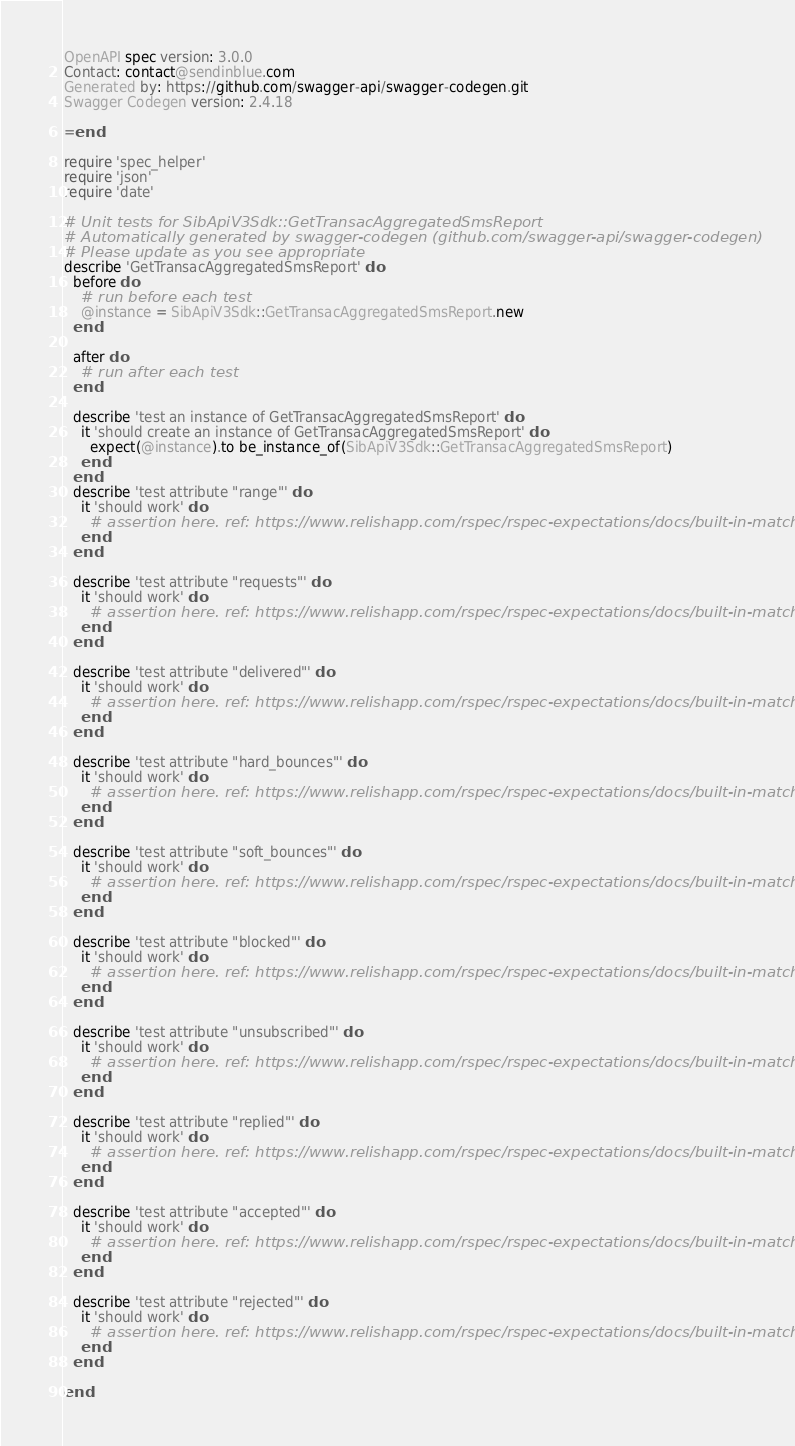Convert code to text. <code><loc_0><loc_0><loc_500><loc_500><_Ruby_>
OpenAPI spec version: 3.0.0
Contact: contact@sendinblue.com
Generated by: https://github.com/swagger-api/swagger-codegen.git
Swagger Codegen version: 2.4.18

=end

require 'spec_helper'
require 'json'
require 'date'

# Unit tests for SibApiV3Sdk::GetTransacAggregatedSmsReport
# Automatically generated by swagger-codegen (github.com/swagger-api/swagger-codegen)
# Please update as you see appropriate
describe 'GetTransacAggregatedSmsReport' do
  before do
    # run before each test
    @instance = SibApiV3Sdk::GetTransacAggregatedSmsReport.new
  end

  after do
    # run after each test
  end

  describe 'test an instance of GetTransacAggregatedSmsReport' do
    it 'should create an instance of GetTransacAggregatedSmsReport' do
      expect(@instance).to be_instance_of(SibApiV3Sdk::GetTransacAggregatedSmsReport)
    end
  end
  describe 'test attribute "range"' do
    it 'should work' do
      # assertion here. ref: https://www.relishapp.com/rspec/rspec-expectations/docs/built-in-matchers
    end
  end

  describe 'test attribute "requests"' do
    it 'should work' do
      # assertion here. ref: https://www.relishapp.com/rspec/rspec-expectations/docs/built-in-matchers
    end
  end

  describe 'test attribute "delivered"' do
    it 'should work' do
      # assertion here. ref: https://www.relishapp.com/rspec/rspec-expectations/docs/built-in-matchers
    end
  end

  describe 'test attribute "hard_bounces"' do
    it 'should work' do
      # assertion here. ref: https://www.relishapp.com/rspec/rspec-expectations/docs/built-in-matchers
    end
  end

  describe 'test attribute "soft_bounces"' do
    it 'should work' do
      # assertion here. ref: https://www.relishapp.com/rspec/rspec-expectations/docs/built-in-matchers
    end
  end

  describe 'test attribute "blocked"' do
    it 'should work' do
      # assertion here. ref: https://www.relishapp.com/rspec/rspec-expectations/docs/built-in-matchers
    end
  end

  describe 'test attribute "unsubscribed"' do
    it 'should work' do
      # assertion here. ref: https://www.relishapp.com/rspec/rspec-expectations/docs/built-in-matchers
    end
  end

  describe 'test attribute "replied"' do
    it 'should work' do
      # assertion here. ref: https://www.relishapp.com/rspec/rspec-expectations/docs/built-in-matchers
    end
  end

  describe 'test attribute "accepted"' do
    it 'should work' do
      # assertion here. ref: https://www.relishapp.com/rspec/rspec-expectations/docs/built-in-matchers
    end
  end

  describe 'test attribute "rejected"' do
    it 'should work' do
      # assertion here. ref: https://www.relishapp.com/rspec/rspec-expectations/docs/built-in-matchers
    end
  end

end
</code> 